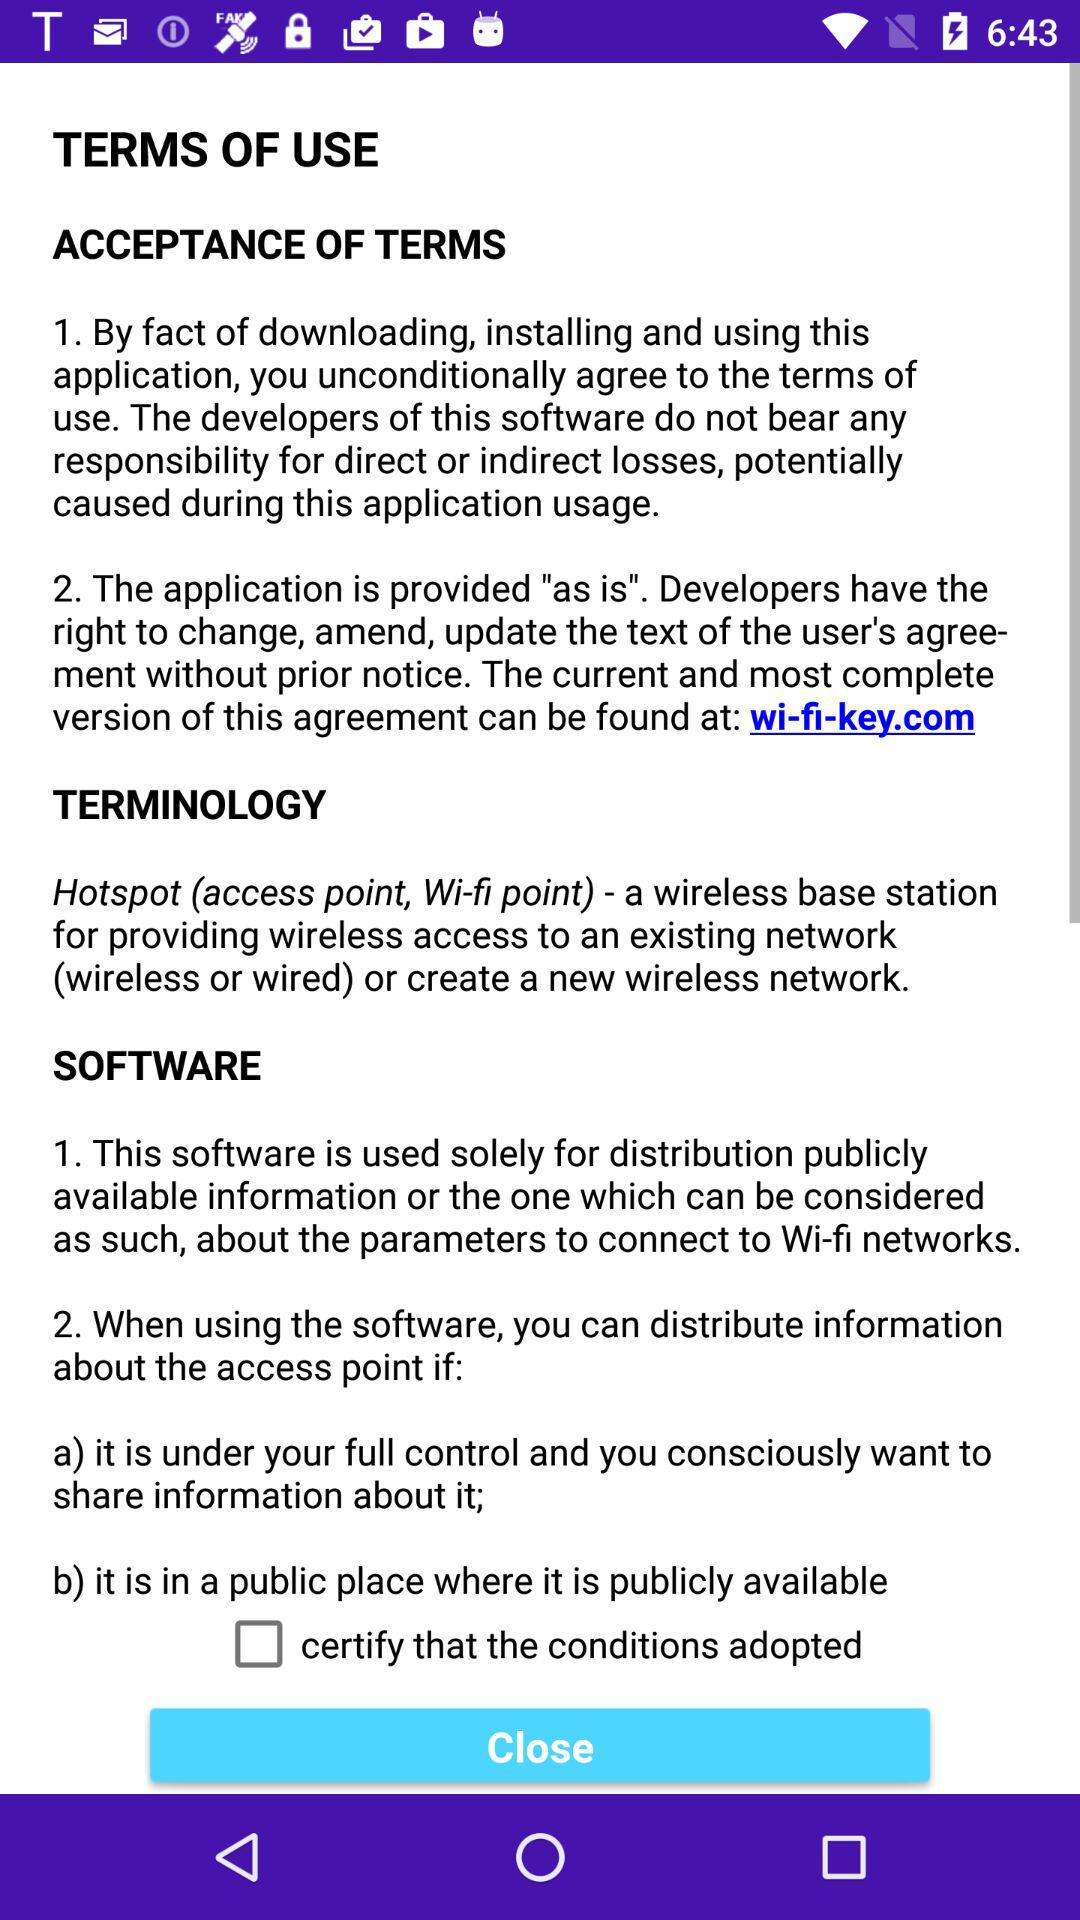What is Terminology?
When the provided information is insufficient, respond with <no answer>. <no answer> 